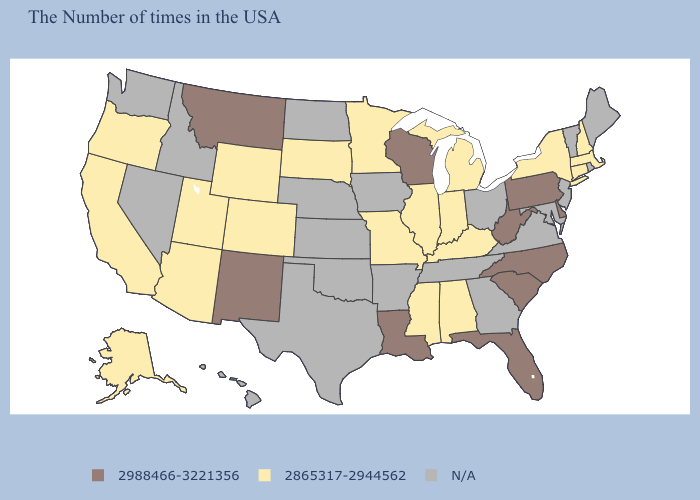Name the states that have a value in the range 2865317-2944562?
Short answer required. Massachusetts, New Hampshire, Connecticut, New York, Michigan, Kentucky, Indiana, Alabama, Illinois, Mississippi, Missouri, Minnesota, South Dakota, Wyoming, Colorado, Utah, Arizona, California, Oregon, Alaska. Does North Carolina have the highest value in the South?
Answer briefly. Yes. Does the first symbol in the legend represent the smallest category?
Quick response, please. No. Which states have the lowest value in the USA?
Give a very brief answer. Massachusetts, New Hampshire, Connecticut, New York, Michigan, Kentucky, Indiana, Alabama, Illinois, Mississippi, Missouri, Minnesota, South Dakota, Wyoming, Colorado, Utah, Arizona, California, Oregon, Alaska. Does the map have missing data?
Keep it brief. Yes. Name the states that have a value in the range N/A?
Be succinct. Maine, Rhode Island, Vermont, New Jersey, Maryland, Virginia, Ohio, Georgia, Tennessee, Arkansas, Iowa, Kansas, Nebraska, Oklahoma, Texas, North Dakota, Idaho, Nevada, Washington, Hawaii. Name the states that have a value in the range 2988466-3221356?
Concise answer only. Delaware, Pennsylvania, North Carolina, South Carolina, West Virginia, Florida, Wisconsin, Louisiana, New Mexico, Montana. What is the value of Michigan?
Give a very brief answer. 2865317-2944562. Name the states that have a value in the range N/A?
Quick response, please. Maine, Rhode Island, Vermont, New Jersey, Maryland, Virginia, Ohio, Georgia, Tennessee, Arkansas, Iowa, Kansas, Nebraska, Oklahoma, Texas, North Dakota, Idaho, Nevada, Washington, Hawaii. What is the value of Mississippi?
Keep it brief. 2865317-2944562. Does Pennsylvania have the highest value in the Northeast?
Write a very short answer. Yes. Which states have the lowest value in the Northeast?
Answer briefly. Massachusetts, New Hampshire, Connecticut, New York. Does Wisconsin have the lowest value in the USA?
Answer briefly. No. Name the states that have a value in the range 2865317-2944562?
Give a very brief answer. Massachusetts, New Hampshire, Connecticut, New York, Michigan, Kentucky, Indiana, Alabama, Illinois, Mississippi, Missouri, Minnesota, South Dakota, Wyoming, Colorado, Utah, Arizona, California, Oregon, Alaska. What is the value of Vermont?
Keep it brief. N/A. 